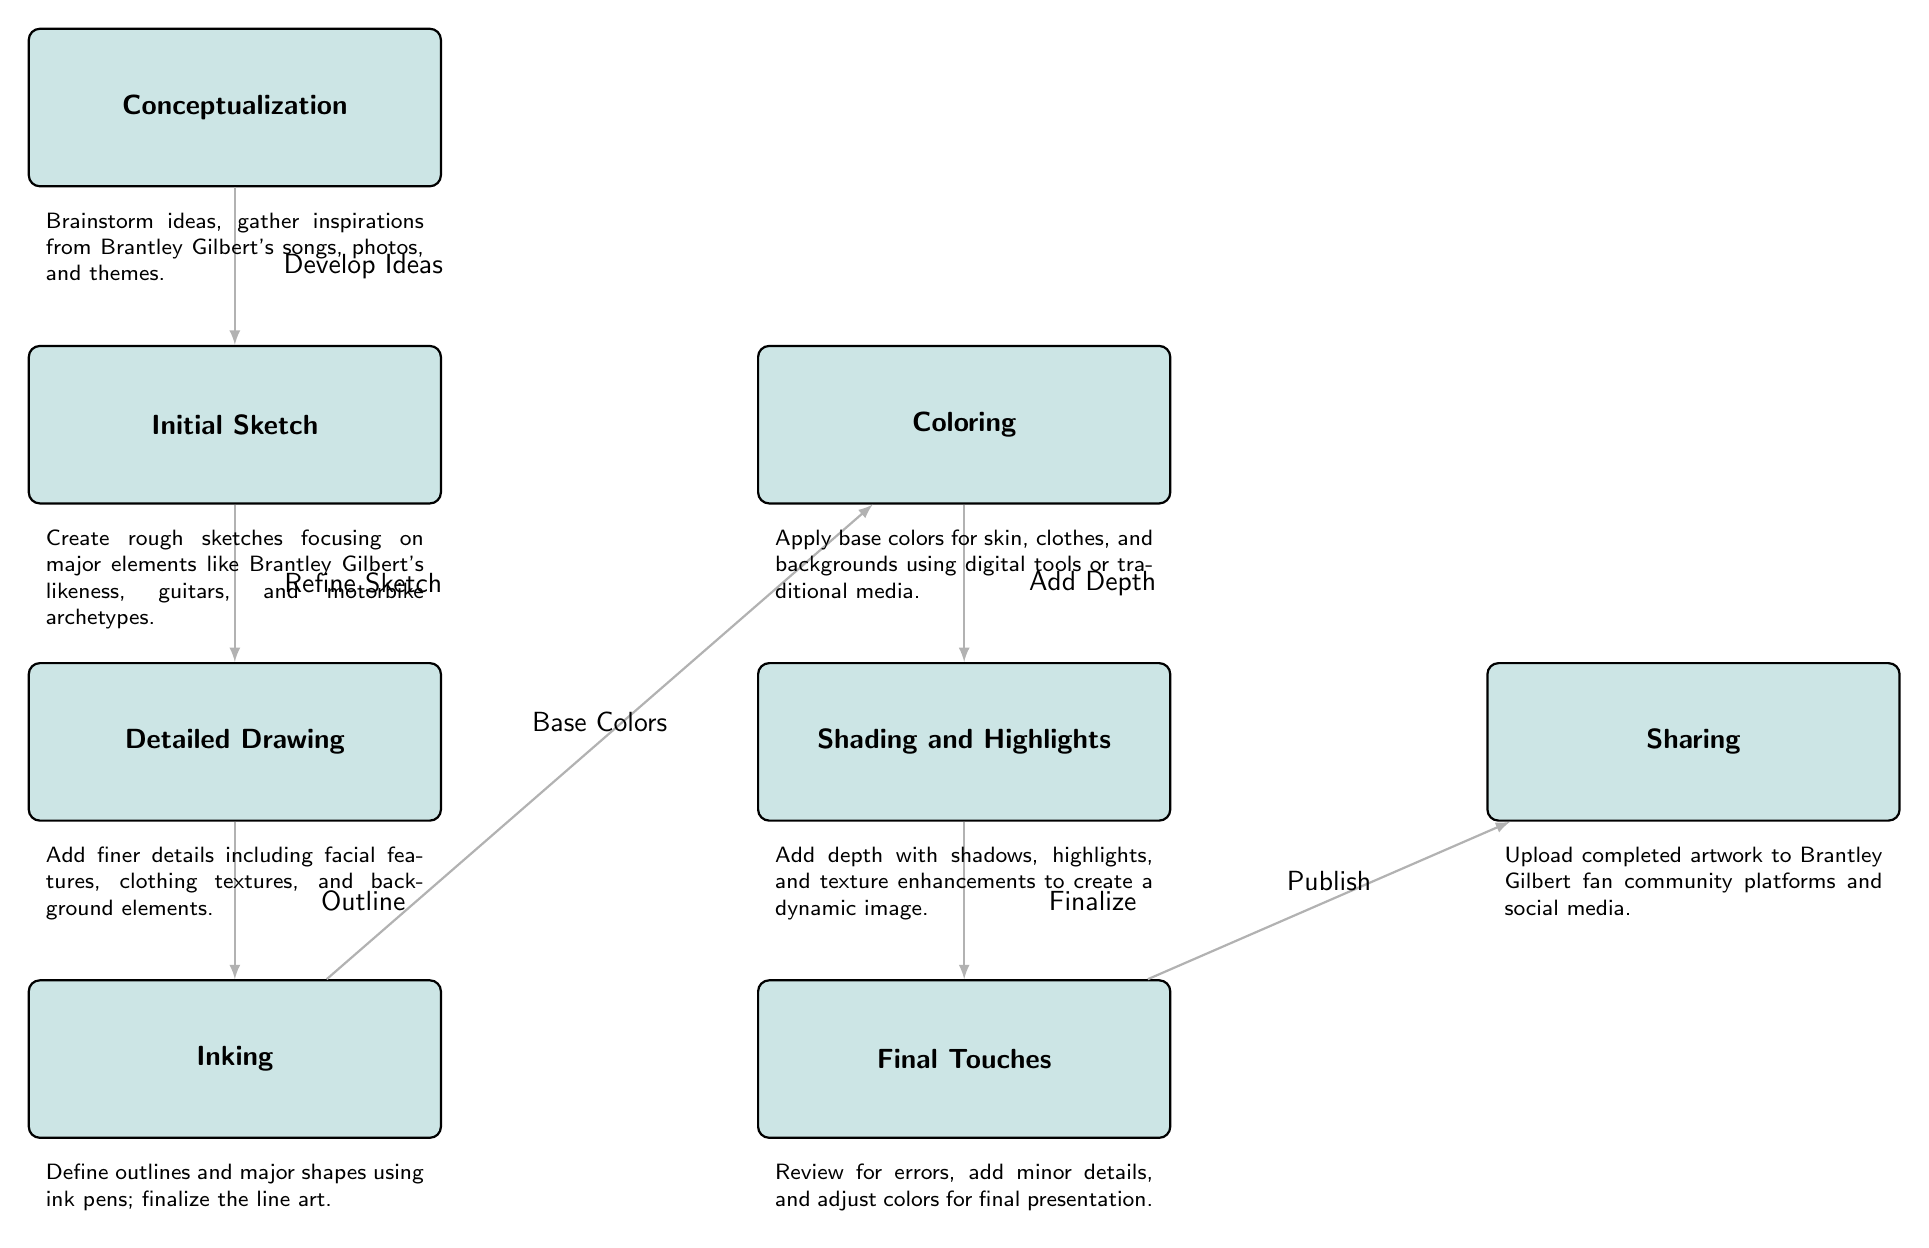What are the seven stages of creating Brantley Gilbert fan art? The diagram presents seven distinct stages: Conceptualization, Initial Sketch, Detailed Drawing, Inking, Coloring, Shading and Highlights, Final Touches, and Sharing. These stages are laid out in order, showing the progression of the artistic process.
Answer: Conceptualization, Initial Sketch, Detailed Drawing, Inking, Coloring, Shading and Highlights, Final Touches, Sharing How many arrows are present in the diagram? Each stage in the process has a directional arrow connecting to the next stage. By counting the arrows depicted in the diagram, we find that there are a total of six arrows indicating the flow of the fan art creation process.
Answer: Six What is the action taken during the transition from Initial Sketch to Detailed Drawing? The transition between these two stages is marked by the action "Refine Sketch." This indicates that during this step, the artist focuses on enhancing the rough draft from the Initial Sketch into a more polished version.
Answer: Refine Sketch Which stage comes after Inking? Following the Inking stage, the next step in the fan art creation process is Coloring. This is where the artist applies the initial colors to the artwork, laying down the base for further detailing.
Answer: Coloring What is emphasized in the stage of Shading and Highlights? In this stage, the emphasis is on adding depth to the artwork. This involves applying shadows and highlights to create a more three-dimensional effect, enhancing the overall visual appeal of the piece.
Answer: Add Depth Which two stages occur concurrently with Coloring? The stage that occurs alongside Coloring is Shading and Highlights. This shows that while applying base colors, the artist also works on providing depth and texture to the artwork, demonstrating an overlap in their artistic workflow.
Answer: Shading and Highlights What is the final action before the artwork is shared? Just before sharing the artwork with the community, the final touch is to "Review for errors." This critical step ensures that the artwork is polished and ready for presentation, allowing for any last-minute adjustments before publishing.
Answer: Review for errors 